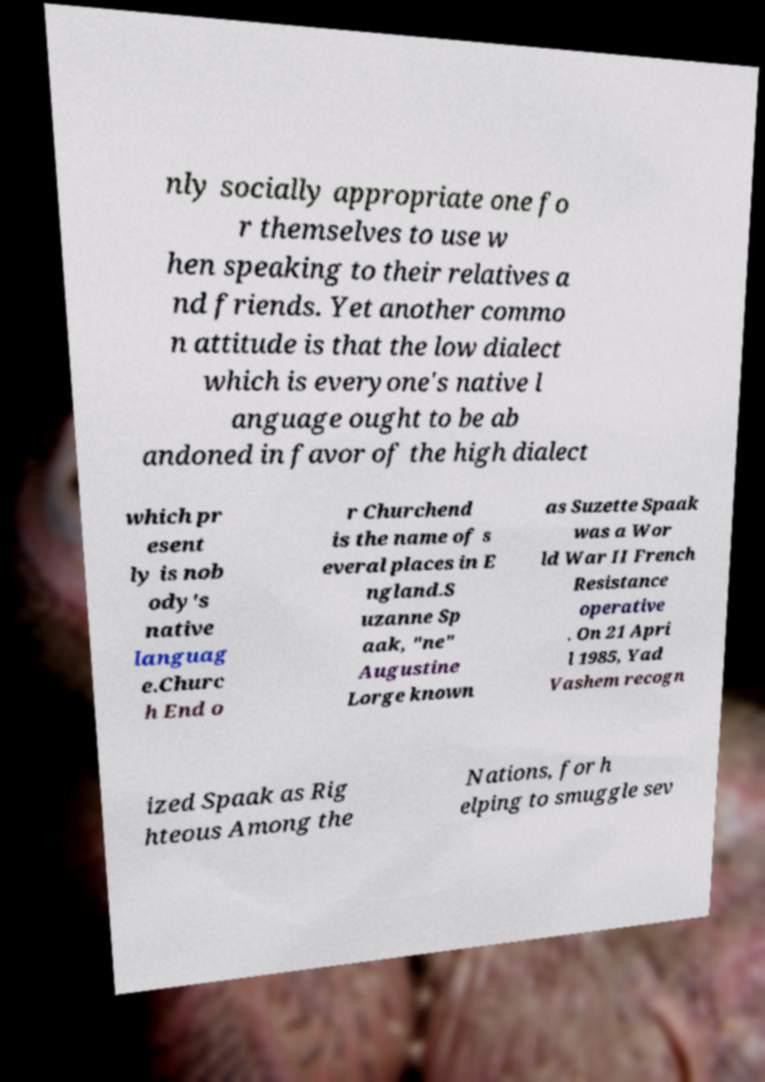For documentation purposes, I need the text within this image transcribed. Could you provide that? nly socially appropriate one fo r themselves to use w hen speaking to their relatives a nd friends. Yet another commo n attitude is that the low dialect which is everyone's native l anguage ought to be ab andoned in favor of the high dialect which pr esent ly is nob ody's native languag e.Churc h End o r Churchend is the name of s everal places in E ngland.S uzanne Sp aak, "ne" Augustine Lorge known as Suzette Spaak was a Wor ld War II French Resistance operative . On 21 Apri l 1985, Yad Vashem recogn ized Spaak as Rig hteous Among the Nations, for h elping to smuggle sev 